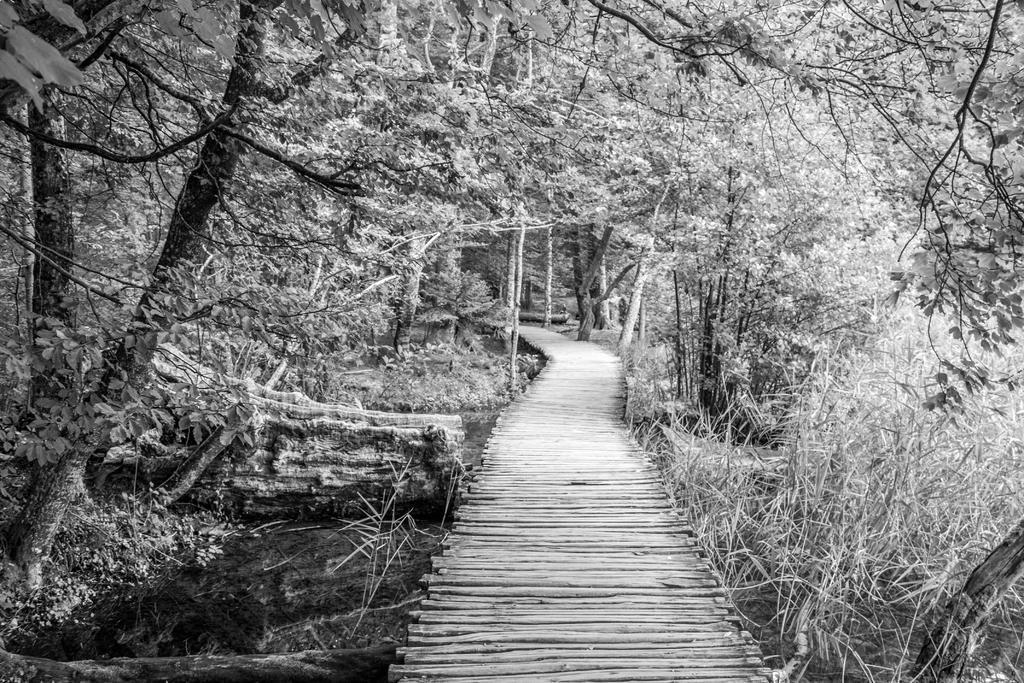Can you describe this image briefly? In this image I can see a path and I can see the number of trees. I can see this image is black and white in colour. 